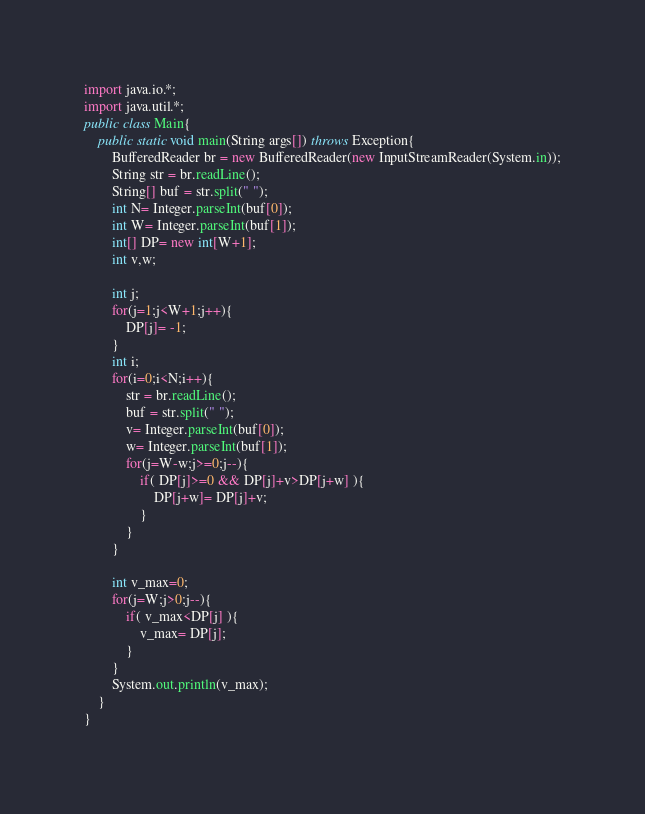<code> <loc_0><loc_0><loc_500><loc_500><_Java_>import java.io.*;
import java.util.*;
public class Main{
	public static void main(String args[]) throws Exception{
		BufferedReader br = new BufferedReader(new InputStreamReader(System.in));
		String str = br.readLine();
		String[] buf = str.split(" ");
		int N= Integer.parseInt(buf[0]);
		int W= Integer.parseInt(buf[1]);
		int[] DP= new int[W+1];
		int v,w;
		
		int j;
		for(j=1;j<W+1;j++){
			DP[j]= -1;
		}
		int i;
		for(i=0;i<N;i++){
			str = br.readLine();
			buf = str.split(" ");
			v= Integer.parseInt(buf[0]);
			w= Integer.parseInt(buf[1]);
			for(j=W-w;j>=0;j--){
				if( DP[j]>=0 && DP[j]+v>DP[j+w] ){
					DP[j+w]= DP[j]+v;
				}
			}
		}
		
		int v_max=0;
		for(j=W;j>0;j--){
			if( v_max<DP[j] ){
				v_max= DP[j];
			}
		}
		System.out.println(v_max);
	}
}</code> 